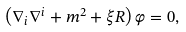Convert formula to latex. <formula><loc_0><loc_0><loc_500><loc_500>\left ( \nabla _ { i } \nabla ^ { i } + m ^ { 2 } + \xi R \right ) \varphi = 0 ,</formula> 